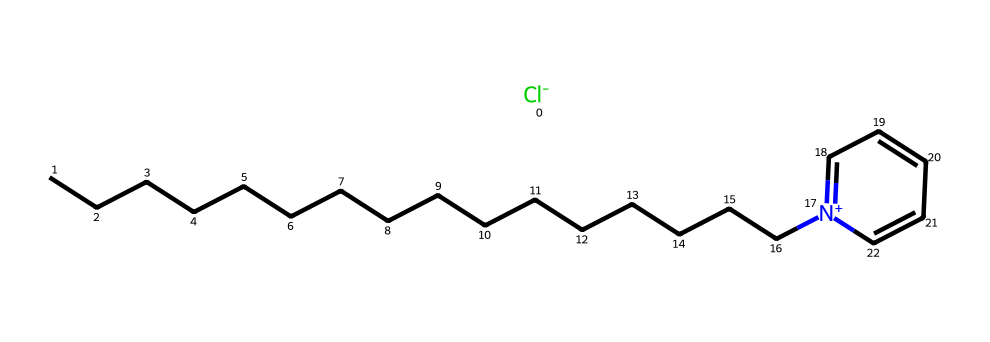What is the molecular formula of cetylpyridinium chloride? To determine the molecular formula, we can count the number of carbon (C), hydrogen (H), chlorine (Cl), and nitrogen (N) atoms in the SMILES representation. The long carbon chain (CCCCCCCCCCCCCCCC) indicates 16 carbon atoms, the pyridine ring contributes 5 carbon atoms, and there is 1 nitrogen and 1 chlorine, resulting in a total of 16 carbon atoms, 33 hydrogen atoms, 1 nitrogen atom, and 1 chlorine atom. The formula is C16H33NCl.
Answer: C16H33NCl How many carbon atoms are in cetylpyridinium chloride? By analyzing the carbon chain and the pyridine ring in the chemical structure, we find that there are 16 carbon atoms present in total.
Answer: 16 What type of surfactant is cetylpyridinium chloride? Cetylpyridinium chloride is a quaternary ammonium compound, which is a type of cationic surfactant. Cationic surfactants have a positively charged nitrogen atom, and they reduce surface tension and help in the emulsification and cleansing processes.
Answer: cationic What is the role of the nitrogen atom in cetylpyridinium chloride? The nitrogen atom in cetylpyridinium chloride carries a positive charge due to it being part of the quaternary ammonium structure. This positive charge enhances its surfactant properties, allowing it to interact well with negatively charged surfaces and bacteria, making it effective as an antiseptic.
Answer: antiseptic Does cetylpyridinium chloride contain a ring structure? Yes, cetylpyridinium chloride contains a pyridine ring structure as shown by the part [N+]1=CC=CC=C1 in the SMILES representation, indicating it has a cyclic arrangement of atoms.
Answer: yes 